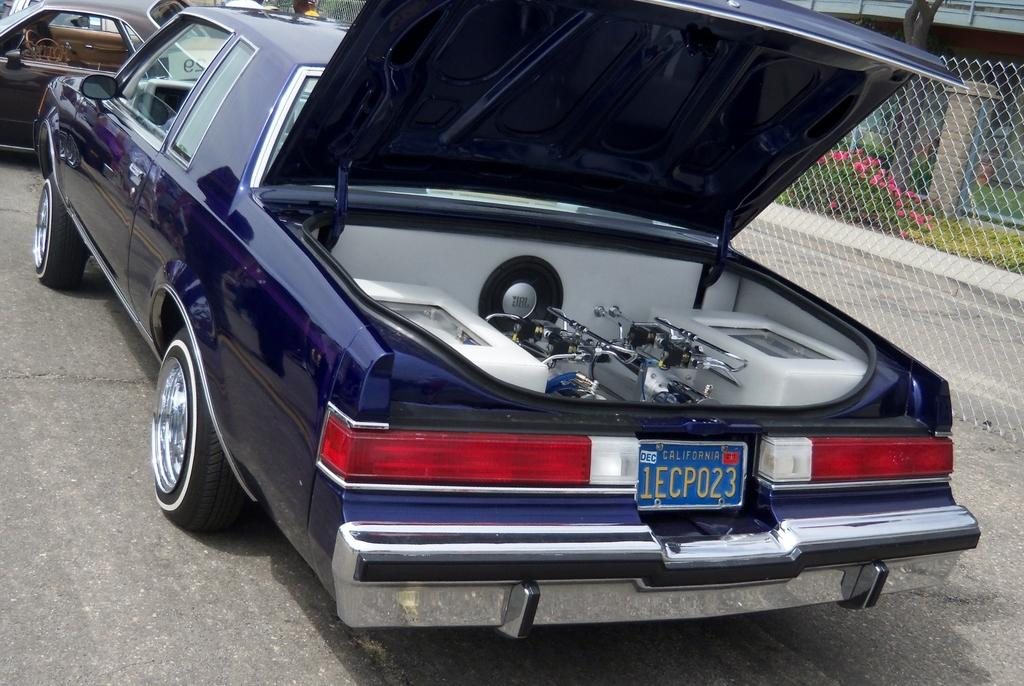Provide a one-sentence caption for the provided image. A blue car with California plate 1ECP023 sits in a parking lot with the window down and the trunk open. 